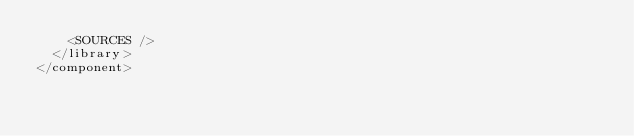Convert code to text. <code><loc_0><loc_0><loc_500><loc_500><_XML_>    <SOURCES />
  </library>
</component></code> 